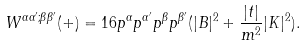Convert formula to latex. <formula><loc_0><loc_0><loc_500><loc_500>W ^ { \alpha \alpha ^ { \prime } ; \beta \beta ^ { \prime } } ( + ) = 1 6 p ^ { \alpha } p ^ { \alpha ^ { \prime } } p ^ { \beta } p ^ { \beta ^ { \prime } } ( | B | ^ { 2 } + \frac { | t | } { m ^ { 2 } } | K | ^ { 2 } ) .</formula> 